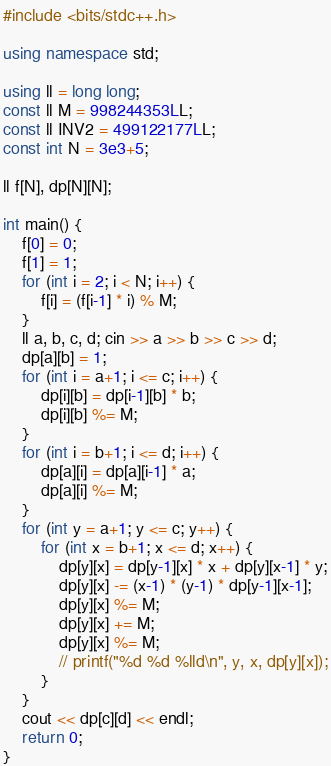<code> <loc_0><loc_0><loc_500><loc_500><_C++_>#include <bits/stdc++.h>

using namespace std;

using ll = long long;
const ll M = 998244353LL;
const ll INV2 = 499122177LL;
const int N = 3e3+5;

ll f[N], dp[N][N];

int main() {
    f[0] = 0;
    f[1] = 1;
    for (int i = 2; i < N; i++) {
        f[i] = (f[i-1] * i) % M;
    }
    ll a, b, c, d; cin >> a >> b >> c >> d;
    dp[a][b] = 1;
    for (int i = a+1; i <= c; i++) {
        dp[i][b] = dp[i-1][b] * b;
        dp[i][b] %= M;
    }
    for (int i = b+1; i <= d; i++) {
        dp[a][i] = dp[a][i-1] * a;
        dp[a][i] %= M;
    }
    for (int y = a+1; y <= c; y++) {
        for (int x = b+1; x <= d; x++) {
            dp[y][x] = dp[y-1][x] * x + dp[y][x-1] * y;
            dp[y][x] -= (x-1) * (y-1) * dp[y-1][x-1];
            dp[y][x] %= M;
            dp[y][x] += M;
            dp[y][x] %= M;
            // printf("%d %d %lld\n", y, x, dp[y][x]);
        }
    }
    cout << dp[c][d] << endl;
    return 0;
}</code> 